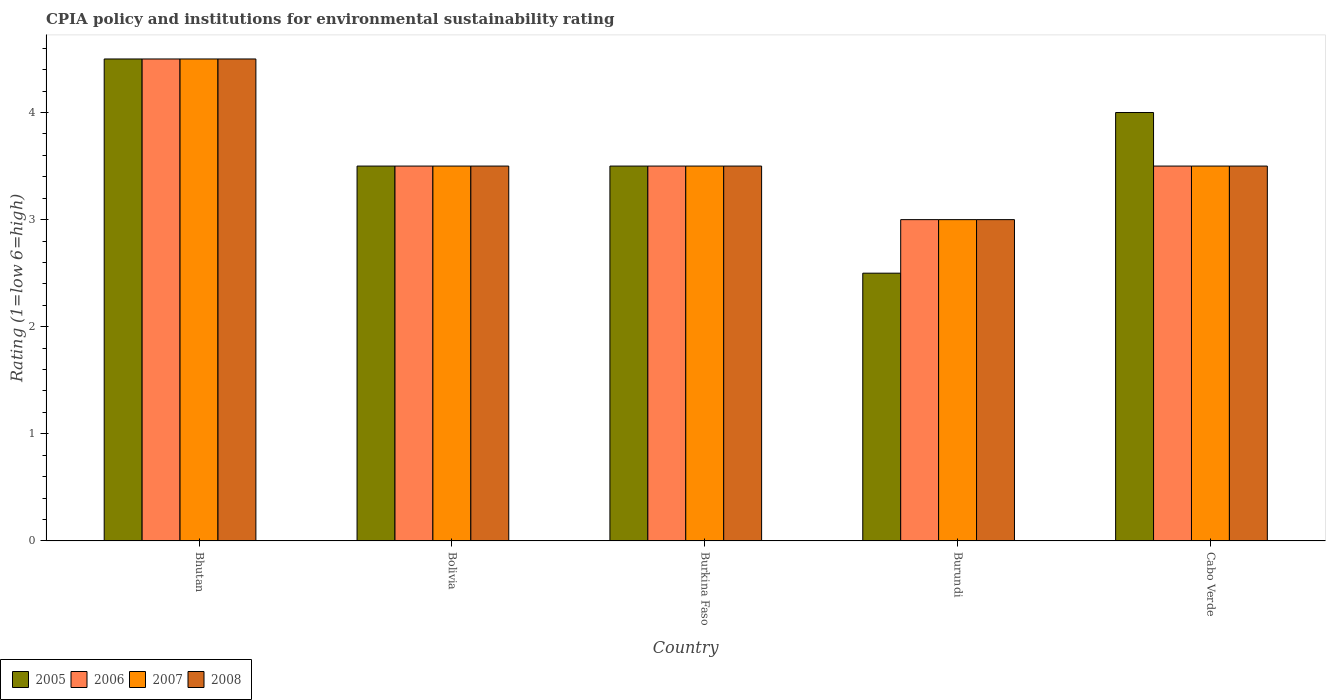Are the number of bars per tick equal to the number of legend labels?
Give a very brief answer. Yes. How many bars are there on the 3rd tick from the left?
Offer a very short reply. 4. How many bars are there on the 2nd tick from the right?
Offer a terse response. 4. What is the label of the 1st group of bars from the left?
Provide a succinct answer. Bhutan. In how many cases, is the number of bars for a given country not equal to the number of legend labels?
Make the answer very short. 0. What is the CPIA rating in 2006 in Burkina Faso?
Your response must be concise. 3.5. Across all countries, what is the minimum CPIA rating in 2008?
Offer a very short reply. 3. In which country was the CPIA rating in 2007 maximum?
Offer a very short reply. Bhutan. In which country was the CPIA rating in 2008 minimum?
Provide a short and direct response. Burundi. What is the total CPIA rating in 2006 in the graph?
Offer a terse response. 18. What is the difference between the CPIA rating of/in 2005 and CPIA rating of/in 2007 in Cabo Verde?
Provide a short and direct response. 0.5. In how many countries, is the CPIA rating in 2008 greater than 1.2?
Make the answer very short. 5. Is the difference between the CPIA rating in 2005 in Bhutan and Cabo Verde greater than the difference between the CPIA rating in 2007 in Bhutan and Cabo Verde?
Your answer should be very brief. No. What is the difference between the highest and the second highest CPIA rating in 2006?
Offer a very short reply. -1. In how many countries, is the CPIA rating in 2007 greater than the average CPIA rating in 2007 taken over all countries?
Offer a very short reply. 1. Is the sum of the CPIA rating in 2005 in Burkina Faso and Burundi greater than the maximum CPIA rating in 2008 across all countries?
Provide a succinct answer. Yes. What does the 2nd bar from the left in Bhutan represents?
Give a very brief answer. 2006. How many bars are there?
Provide a succinct answer. 20. Does the graph contain any zero values?
Offer a very short reply. No. How many legend labels are there?
Your response must be concise. 4. How are the legend labels stacked?
Provide a short and direct response. Horizontal. What is the title of the graph?
Provide a succinct answer. CPIA policy and institutions for environmental sustainability rating. Does "2001" appear as one of the legend labels in the graph?
Offer a very short reply. No. What is the label or title of the Y-axis?
Make the answer very short. Rating (1=low 6=high). What is the Rating (1=low 6=high) in 2005 in Bhutan?
Provide a short and direct response. 4.5. What is the Rating (1=low 6=high) of 2006 in Bhutan?
Your answer should be compact. 4.5. What is the Rating (1=low 6=high) in 2007 in Bhutan?
Give a very brief answer. 4.5. What is the Rating (1=low 6=high) in 2008 in Bhutan?
Keep it short and to the point. 4.5. What is the Rating (1=low 6=high) in 2005 in Bolivia?
Your answer should be very brief. 3.5. What is the Rating (1=low 6=high) of 2006 in Bolivia?
Provide a short and direct response. 3.5. What is the Rating (1=low 6=high) in 2007 in Bolivia?
Your answer should be compact. 3.5. What is the Rating (1=low 6=high) of 2008 in Bolivia?
Provide a succinct answer. 3.5. What is the Rating (1=low 6=high) in 2007 in Burkina Faso?
Make the answer very short. 3.5. What is the Rating (1=low 6=high) of 2008 in Burkina Faso?
Provide a succinct answer. 3.5. What is the Rating (1=low 6=high) in 2005 in Burundi?
Keep it short and to the point. 2.5. What is the Rating (1=low 6=high) in 2006 in Burundi?
Your response must be concise. 3. What is the Rating (1=low 6=high) of 2007 in Burundi?
Your response must be concise. 3. What is the Rating (1=low 6=high) in 2005 in Cabo Verde?
Your response must be concise. 4. What is the Rating (1=low 6=high) in 2008 in Cabo Verde?
Offer a very short reply. 3.5. Across all countries, what is the maximum Rating (1=low 6=high) of 2006?
Make the answer very short. 4.5. Across all countries, what is the minimum Rating (1=low 6=high) in 2006?
Offer a very short reply. 3. Across all countries, what is the minimum Rating (1=low 6=high) of 2007?
Your answer should be very brief. 3. Across all countries, what is the minimum Rating (1=low 6=high) in 2008?
Your answer should be compact. 3. What is the total Rating (1=low 6=high) in 2007 in the graph?
Offer a very short reply. 18. What is the total Rating (1=low 6=high) in 2008 in the graph?
Your answer should be compact. 18. What is the difference between the Rating (1=low 6=high) in 2005 in Bhutan and that in Bolivia?
Offer a very short reply. 1. What is the difference between the Rating (1=low 6=high) in 2005 in Bhutan and that in Burkina Faso?
Your answer should be very brief. 1. What is the difference between the Rating (1=low 6=high) of 2006 in Bhutan and that in Burkina Faso?
Your response must be concise. 1. What is the difference between the Rating (1=low 6=high) of 2007 in Bhutan and that in Burkina Faso?
Ensure brevity in your answer.  1. What is the difference between the Rating (1=low 6=high) of 2008 in Bhutan and that in Burkina Faso?
Offer a terse response. 1. What is the difference between the Rating (1=low 6=high) of 2006 in Bhutan and that in Burundi?
Your answer should be compact. 1.5. What is the difference between the Rating (1=low 6=high) in 2007 in Bhutan and that in Cabo Verde?
Keep it short and to the point. 1. What is the difference between the Rating (1=low 6=high) in 2008 in Bhutan and that in Cabo Verde?
Offer a very short reply. 1. What is the difference between the Rating (1=low 6=high) in 2006 in Bolivia and that in Burkina Faso?
Ensure brevity in your answer.  0. What is the difference between the Rating (1=low 6=high) of 2005 in Bolivia and that in Burundi?
Your response must be concise. 1. What is the difference between the Rating (1=low 6=high) in 2008 in Bolivia and that in Burundi?
Provide a short and direct response. 0.5. What is the difference between the Rating (1=low 6=high) of 2008 in Bolivia and that in Cabo Verde?
Your response must be concise. 0. What is the difference between the Rating (1=low 6=high) in 2005 in Burkina Faso and that in Cabo Verde?
Offer a very short reply. -0.5. What is the difference between the Rating (1=low 6=high) of 2006 in Burkina Faso and that in Cabo Verde?
Your answer should be very brief. 0. What is the difference between the Rating (1=low 6=high) of 2007 in Burkina Faso and that in Cabo Verde?
Offer a very short reply. 0. What is the difference between the Rating (1=low 6=high) of 2008 in Burkina Faso and that in Cabo Verde?
Your answer should be compact. 0. What is the difference between the Rating (1=low 6=high) of 2005 in Bhutan and the Rating (1=low 6=high) of 2006 in Bolivia?
Give a very brief answer. 1. What is the difference between the Rating (1=low 6=high) of 2005 in Bhutan and the Rating (1=low 6=high) of 2007 in Bolivia?
Provide a short and direct response. 1. What is the difference between the Rating (1=low 6=high) in 2005 in Bhutan and the Rating (1=low 6=high) in 2008 in Bolivia?
Your answer should be very brief. 1. What is the difference between the Rating (1=low 6=high) in 2007 in Bhutan and the Rating (1=low 6=high) in 2008 in Bolivia?
Keep it short and to the point. 1. What is the difference between the Rating (1=low 6=high) of 2005 in Bhutan and the Rating (1=low 6=high) of 2007 in Burkina Faso?
Provide a succinct answer. 1. What is the difference between the Rating (1=low 6=high) in 2005 in Bhutan and the Rating (1=low 6=high) in 2008 in Burkina Faso?
Provide a succinct answer. 1. What is the difference between the Rating (1=low 6=high) in 2006 in Bhutan and the Rating (1=low 6=high) in 2007 in Burkina Faso?
Provide a short and direct response. 1. What is the difference between the Rating (1=low 6=high) of 2007 in Bhutan and the Rating (1=low 6=high) of 2008 in Burkina Faso?
Your answer should be compact. 1. What is the difference between the Rating (1=low 6=high) of 2005 in Bhutan and the Rating (1=low 6=high) of 2008 in Burundi?
Provide a succinct answer. 1.5. What is the difference between the Rating (1=low 6=high) in 2005 in Bhutan and the Rating (1=low 6=high) in 2008 in Cabo Verde?
Your answer should be very brief. 1. What is the difference between the Rating (1=low 6=high) of 2006 in Bhutan and the Rating (1=low 6=high) of 2007 in Cabo Verde?
Keep it short and to the point. 1. What is the difference between the Rating (1=low 6=high) in 2006 in Bhutan and the Rating (1=low 6=high) in 2008 in Cabo Verde?
Offer a very short reply. 1. What is the difference between the Rating (1=low 6=high) in 2005 in Bolivia and the Rating (1=low 6=high) in 2008 in Burkina Faso?
Provide a succinct answer. 0. What is the difference between the Rating (1=low 6=high) of 2007 in Bolivia and the Rating (1=low 6=high) of 2008 in Burkina Faso?
Provide a succinct answer. 0. What is the difference between the Rating (1=low 6=high) in 2005 in Bolivia and the Rating (1=low 6=high) in 2007 in Burundi?
Make the answer very short. 0.5. What is the difference between the Rating (1=low 6=high) of 2005 in Bolivia and the Rating (1=low 6=high) of 2008 in Burundi?
Keep it short and to the point. 0.5. What is the difference between the Rating (1=low 6=high) of 2007 in Bolivia and the Rating (1=low 6=high) of 2008 in Burundi?
Make the answer very short. 0.5. What is the difference between the Rating (1=low 6=high) of 2005 in Bolivia and the Rating (1=low 6=high) of 2006 in Cabo Verde?
Offer a very short reply. 0. What is the difference between the Rating (1=low 6=high) in 2006 in Bolivia and the Rating (1=low 6=high) in 2007 in Cabo Verde?
Offer a terse response. 0. What is the difference between the Rating (1=low 6=high) in 2006 in Bolivia and the Rating (1=low 6=high) in 2008 in Cabo Verde?
Your answer should be very brief. 0. What is the difference between the Rating (1=low 6=high) of 2007 in Bolivia and the Rating (1=low 6=high) of 2008 in Cabo Verde?
Ensure brevity in your answer.  0. What is the difference between the Rating (1=low 6=high) in 2005 in Burkina Faso and the Rating (1=low 6=high) in 2006 in Burundi?
Offer a very short reply. 0.5. What is the difference between the Rating (1=low 6=high) in 2005 in Burkina Faso and the Rating (1=low 6=high) in 2007 in Burundi?
Keep it short and to the point. 0.5. What is the difference between the Rating (1=low 6=high) of 2006 in Burkina Faso and the Rating (1=low 6=high) of 2007 in Burundi?
Make the answer very short. 0.5. What is the difference between the Rating (1=low 6=high) in 2007 in Burkina Faso and the Rating (1=low 6=high) in 2008 in Burundi?
Your response must be concise. 0.5. What is the difference between the Rating (1=low 6=high) of 2005 in Burkina Faso and the Rating (1=low 6=high) of 2006 in Cabo Verde?
Your response must be concise. 0. What is the difference between the Rating (1=low 6=high) of 2005 in Burkina Faso and the Rating (1=low 6=high) of 2007 in Cabo Verde?
Ensure brevity in your answer.  0. What is the difference between the Rating (1=low 6=high) of 2005 in Burkina Faso and the Rating (1=low 6=high) of 2008 in Cabo Verde?
Keep it short and to the point. 0. What is the difference between the Rating (1=low 6=high) of 2006 in Burkina Faso and the Rating (1=low 6=high) of 2007 in Cabo Verde?
Offer a very short reply. 0. What is the difference between the Rating (1=low 6=high) of 2005 in Burundi and the Rating (1=low 6=high) of 2006 in Cabo Verde?
Your answer should be very brief. -1. What is the difference between the Rating (1=low 6=high) in 2005 in Burundi and the Rating (1=low 6=high) in 2007 in Cabo Verde?
Keep it short and to the point. -1. What is the difference between the Rating (1=low 6=high) in 2006 in Burundi and the Rating (1=low 6=high) in 2008 in Cabo Verde?
Your response must be concise. -0.5. What is the average Rating (1=low 6=high) in 2005 per country?
Keep it short and to the point. 3.6. What is the average Rating (1=low 6=high) of 2007 per country?
Keep it short and to the point. 3.6. What is the difference between the Rating (1=low 6=high) in 2006 and Rating (1=low 6=high) in 2007 in Bhutan?
Offer a very short reply. 0. What is the difference between the Rating (1=low 6=high) of 2006 and Rating (1=low 6=high) of 2008 in Bhutan?
Your response must be concise. 0. What is the difference between the Rating (1=low 6=high) in 2007 and Rating (1=low 6=high) in 2008 in Bhutan?
Make the answer very short. 0. What is the difference between the Rating (1=low 6=high) of 2005 and Rating (1=low 6=high) of 2006 in Bolivia?
Provide a succinct answer. 0. What is the difference between the Rating (1=low 6=high) in 2006 and Rating (1=low 6=high) in 2008 in Bolivia?
Your response must be concise. 0. What is the difference between the Rating (1=low 6=high) of 2005 and Rating (1=low 6=high) of 2007 in Burkina Faso?
Your response must be concise. 0. What is the difference between the Rating (1=low 6=high) in 2005 and Rating (1=low 6=high) in 2008 in Burkina Faso?
Make the answer very short. 0. What is the difference between the Rating (1=low 6=high) in 2006 and Rating (1=low 6=high) in 2007 in Burkina Faso?
Your answer should be very brief. 0. What is the difference between the Rating (1=low 6=high) in 2006 and Rating (1=low 6=high) in 2008 in Burkina Faso?
Keep it short and to the point. 0. What is the difference between the Rating (1=low 6=high) in 2007 and Rating (1=low 6=high) in 2008 in Burkina Faso?
Make the answer very short. 0. What is the difference between the Rating (1=low 6=high) in 2005 and Rating (1=low 6=high) in 2007 in Burundi?
Your answer should be compact. -0.5. What is the difference between the Rating (1=low 6=high) in 2006 and Rating (1=low 6=high) in 2007 in Burundi?
Your answer should be compact. 0. What is the difference between the Rating (1=low 6=high) in 2006 and Rating (1=low 6=high) in 2008 in Burundi?
Your response must be concise. 0. What is the difference between the Rating (1=low 6=high) in 2007 and Rating (1=low 6=high) in 2008 in Burundi?
Your response must be concise. 0. What is the difference between the Rating (1=low 6=high) of 2005 and Rating (1=low 6=high) of 2006 in Cabo Verde?
Your answer should be compact. 0.5. What is the difference between the Rating (1=low 6=high) in 2005 and Rating (1=low 6=high) in 2008 in Cabo Verde?
Give a very brief answer. 0.5. What is the difference between the Rating (1=low 6=high) in 2006 and Rating (1=low 6=high) in 2007 in Cabo Verde?
Give a very brief answer. 0. What is the difference between the Rating (1=low 6=high) of 2006 and Rating (1=low 6=high) of 2008 in Cabo Verde?
Keep it short and to the point. 0. What is the difference between the Rating (1=low 6=high) in 2007 and Rating (1=low 6=high) in 2008 in Cabo Verde?
Offer a very short reply. 0. What is the ratio of the Rating (1=low 6=high) in 2005 in Bhutan to that in Bolivia?
Provide a short and direct response. 1.29. What is the ratio of the Rating (1=low 6=high) of 2006 in Bhutan to that in Bolivia?
Make the answer very short. 1.29. What is the ratio of the Rating (1=low 6=high) of 2007 in Bhutan to that in Bolivia?
Provide a short and direct response. 1.29. What is the ratio of the Rating (1=low 6=high) of 2005 in Bhutan to that in Burkina Faso?
Your response must be concise. 1.29. What is the ratio of the Rating (1=low 6=high) of 2007 in Bhutan to that in Burkina Faso?
Keep it short and to the point. 1.29. What is the ratio of the Rating (1=low 6=high) in 2006 in Bhutan to that in Burundi?
Ensure brevity in your answer.  1.5. What is the ratio of the Rating (1=low 6=high) in 2006 in Bhutan to that in Cabo Verde?
Your answer should be very brief. 1.29. What is the ratio of the Rating (1=low 6=high) in 2007 in Bhutan to that in Cabo Verde?
Your answer should be very brief. 1.29. What is the ratio of the Rating (1=low 6=high) in 2006 in Bolivia to that in Burkina Faso?
Make the answer very short. 1. What is the ratio of the Rating (1=low 6=high) in 2008 in Bolivia to that in Burkina Faso?
Keep it short and to the point. 1. What is the ratio of the Rating (1=low 6=high) of 2005 in Bolivia to that in Burundi?
Ensure brevity in your answer.  1.4. What is the ratio of the Rating (1=low 6=high) of 2006 in Bolivia to that in Burundi?
Your response must be concise. 1.17. What is the ratio of the Rating (1=low 6=high) of 2008 in Bolivia to that in Burundi?
Give a very brief answer. 1.17. What is the ratio of the Rating (1=low 6=high) in 2005 in Bolivia to that in Cabo Verde?
Provide a short and direct response. 0.88. What is the ratio of the Rating (1=low 6=high) in 2007 in Bolivia to that in Cabo Verde?
Your response must be concise. 1. What is the ratio of the Rating (1=low 6=high) of 2005 in Burkina Faso to that in Burundi?
Provide a short and direct response. 1.4. What is the ratio of the Rating (1=low 6=high) of 2005 in Burkina Faso to that in Cabo Verde?
Ensure brevity in your answer.  0.88. What is the ratio of the Rating (1=low 6=high) in 2006 in Burkina Faso to that in Cabo Verde?
Offer a very short reply. 1. What is the ratio of the Rating (1=low 6=high) in 2005 in Burundi to that in Cabo Verde?
Ensure brevity in your answer.  0.62. What is the ratio of the Rating (1=low 6=high) in 2007 in Burundi to that in Cabo Verde?
Provide a succinct answer. 0.86. What is the difference between the highest and the second highest Rating (1=low 6=high) in 2008?
Ensure brevity in your answer.  1. What is the difference between the highest and the lowest Rating (1=low 6=high) of 2005?
Make the answer very short. 2. What is the difference between the highest and the lowest Rating (1=low 6=high) in 2006?
Provide a succinct answer. 1.5. What is the difference between the highest and the lowest Rating (1=low 6=high) in 2008?
Provide a short and direct response. 1.5. 